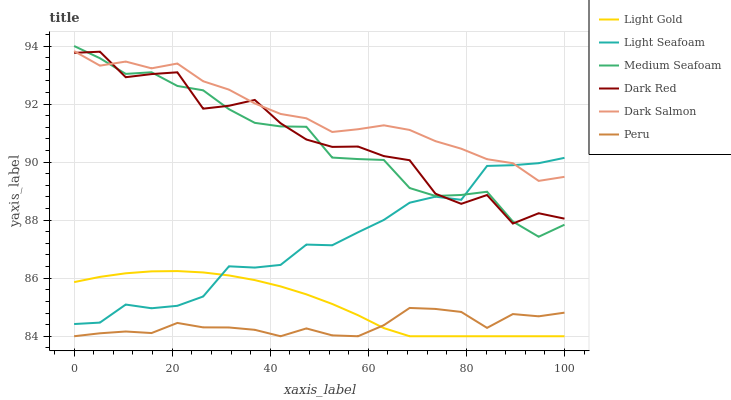Does Dark Salmon have the minimum area under the curve?
Answer yes or no. No. Does Peru have the maximum area under the curve?
Answer yes or no. No. Is Dark Salmon the smoothest?
Answer yes or no. No. Is Dark Salmon the roughest?
Answer yes or no. No. Does Dark Salmon have the lowest value?
Answer yes or no. No. Does Dark Salmon have the highest value?
Answer yes or no. No. Is Peru less than Dark Red?
Answer yes or no. Yes. Is Medium Seafoam greater than Light Gold?
Answer yes or no. Yes. Does Peru intersect Dark Red?
Answer yes or no. No. 